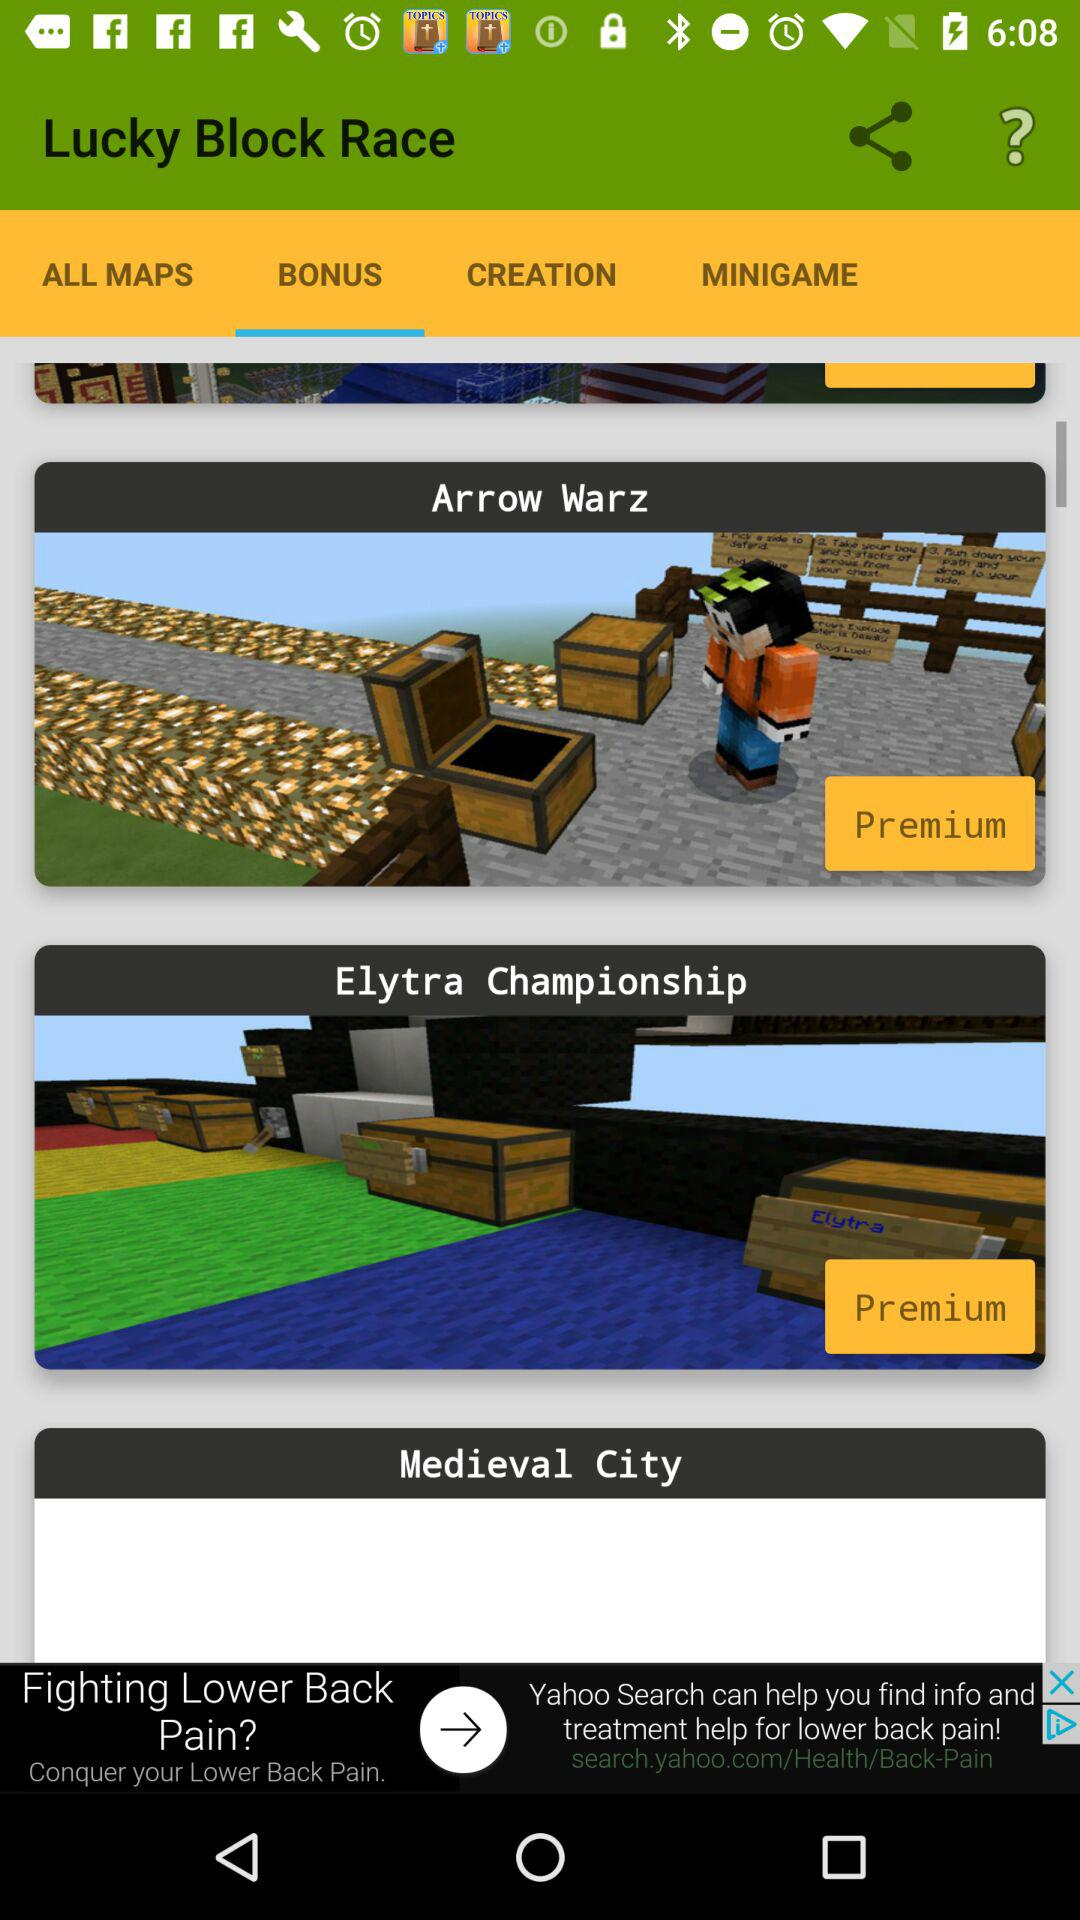How many items are premium?
Answer the question using a single word or phrase. 2 